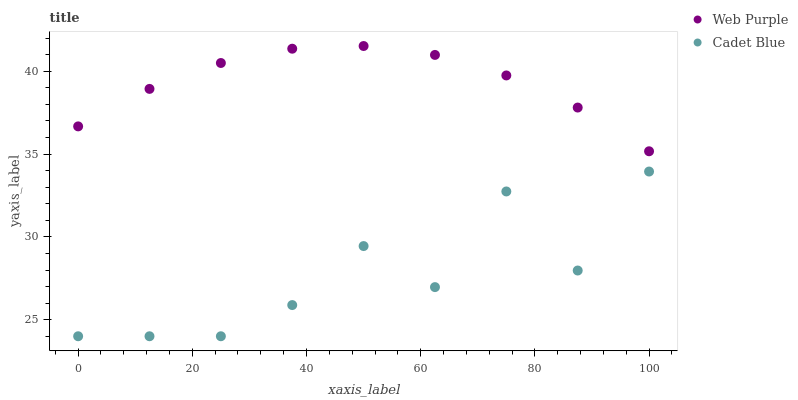Does Cadet Blue have the minimum area under the curve?
Answer yes or no. Yes. Does Web Purple have the maximum area under the curve?
Answer yes or no. Yes. Does Cadet Blue have the maximum area under the curve?
Answer yes or no. No. Is Web Purple the smoothest?
Answer yes or no. Yes. Is Cadet Blue the roughest?
Answer yes or no. Yes. Is Cadet Blue the smoothest?
Answer yes or no. No. Does Cadet Blue have the lowest value?
Answer yes or no. Yes. Does Web Purple have the highest value?
Answer yes or no. Yes. Does Cadet Blue have the highest value?
Answer yes or no. No. Is Cadet Blue less than Web Purple?
Answer yes or no. Yes. Is Web Purple greater than Cadet Blue?
Answer yes or no. Yes. Does Cadet Blue intersect Web Purple?
Answer yes or no. No. 